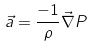<formula> <loc_0><loc_0><loc_500><loc_500>\vec { a } = \frac { - 1 } { \rho } \vec { \nabla } P</formula> 